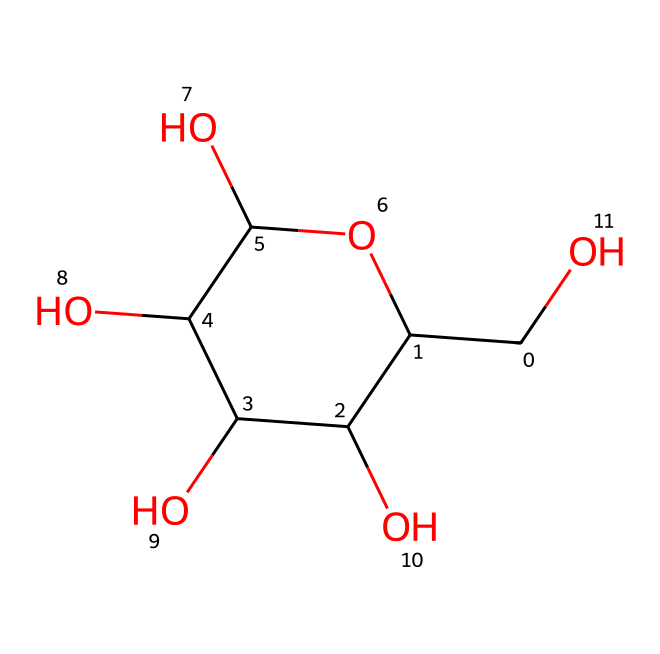What is the molecular formula of glucose represented here? The molecular formula can be determined by counting the number of each type of atom present in the SMILES representation. The structure has six carbons (C), twelve hydrogens (H), and six oxygens (O), which corresponds to C6H12O6.
Answer: C6H12O6 How many hydroxyl (–OH) groups are present in this structure? By examining the structure, each –OH group is attached to a carbon atom. The SMILES representation shows five –OH groups attached at various positions, which can be counted directly.
Answer: 5 What type of carbohydrate is represented by this structure? The structure corresponds to glucose, which is a simple sugar (monosaccharide). This can be concluded because it has the typical structure of monosaccharides with a ring formation and numerous hydroxyl groups.
Answer: monosaccharide How many rings does the glucose molecule contain? The SMILES notation indicates a cyclic structure (the presence of 'C1' suggests a ring), which shows that glucose in this form contains one ring.
Answer: 1 What is the significance of the hydroxyl groups on glucose? The hydroxyl groups on glucose contribute to its solubility in water and play a significant role in biochemical reactions, including its reactivity as an energy source. This is inferred from the presence of multiple –OH groups enhancing its polar nature.
Answer: solubility What role does the chemical structure of glucose play in energy storage? The specific arrangement of atoms and functional groups in glucose allows it to be readily metabolized for energy in biological systems. The presence of simple sugars like glucose is crucial for ATP production through glycolysis. This understanding comes from the observation of its chemical structure which supports energy transfer.
Answer: ATP production 